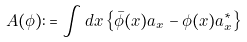Convert formula to latex. <formula><loc_0><loc_0><loc_500><loc_500>\ A ( \phi ) \colon = \int d x \left \{ \bar { \phi } ( x ) a _ { x } - \phi ( x ) a ^ { \ast } _ { x } \right \}</formula> 